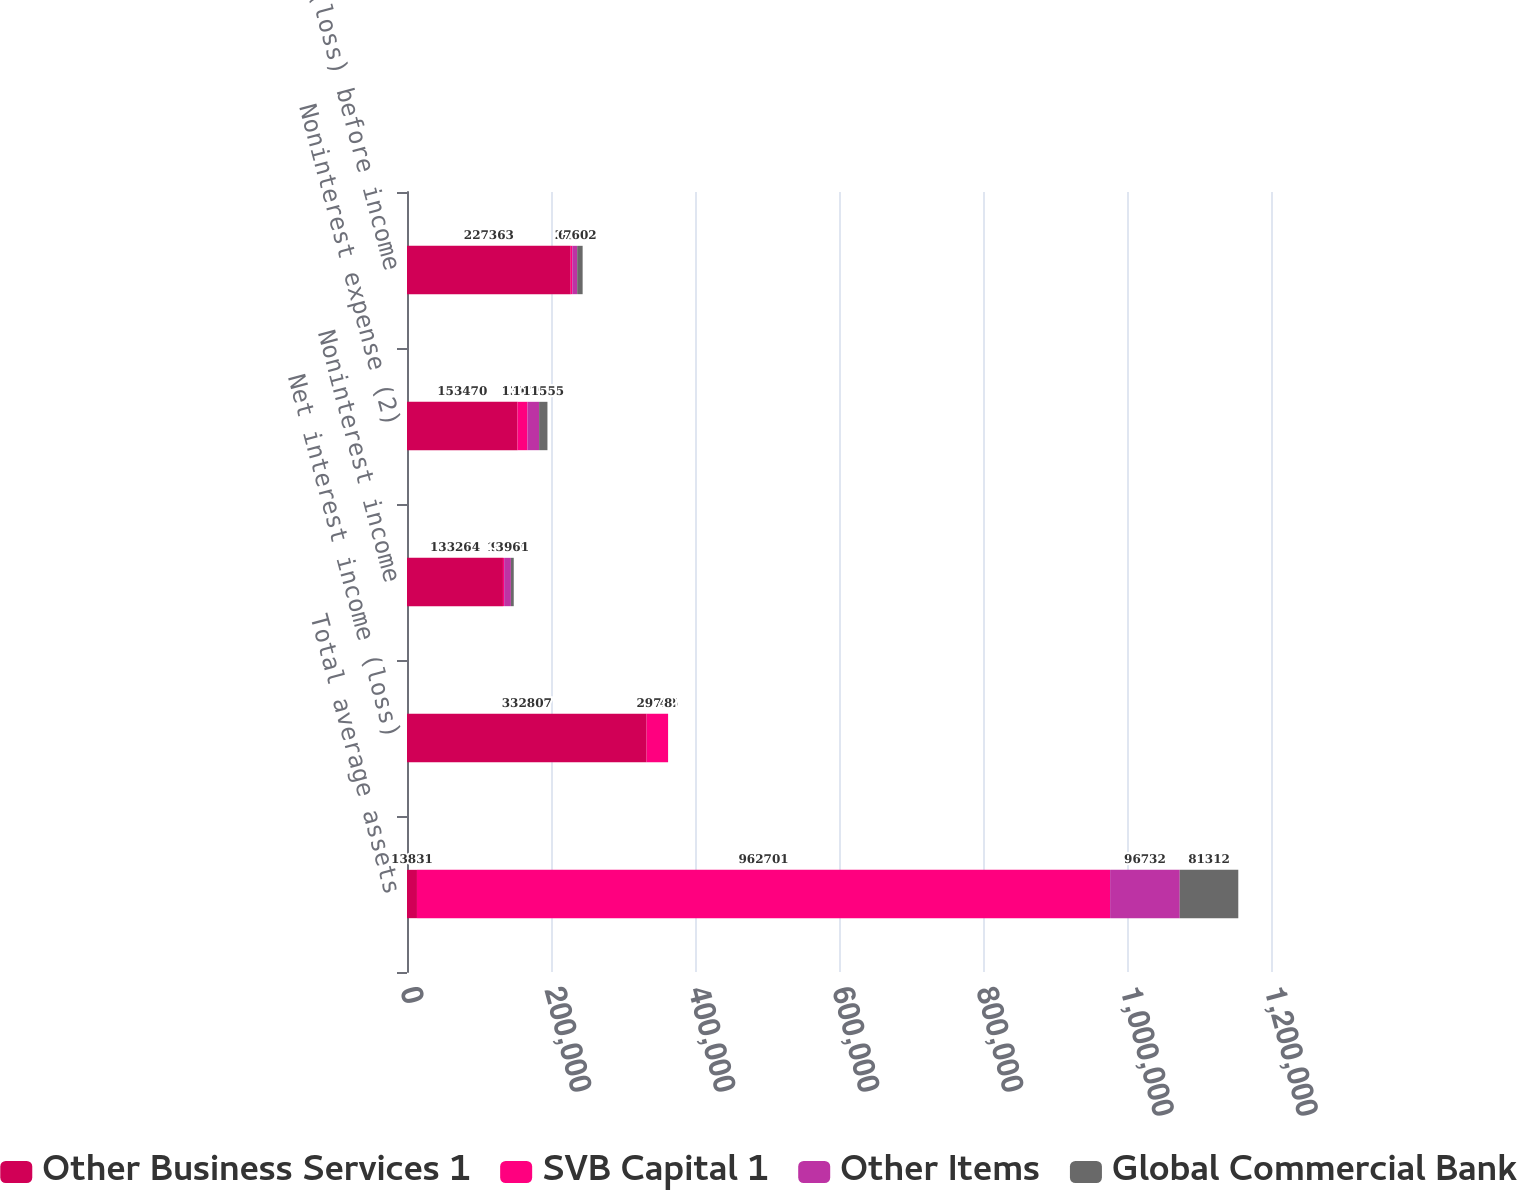<chart> <loc_0><loc_0><loc_500><loc_500><stacked_bar_chart><ecel><fcel>Total average assets<fcel>Net interest income (loss)<fcel>Noninterest income<fcel>Noninterest expense (2)<fcel>Income (loss) before income<nl><fcel>Other Business Services 1<fcel>13831<fcel>332807<fcel>133264<fcel>153470<fcel>227363<nl><fcel>SVB Capital 1<fcel>962701<fcel>29766<fcel>1673<fcel>13831<fcel>2167<nl><fcel>Other Items<fcel>96732<fcel>42<fcel>9360<fcel>16206<fcel>6804<nl><fcel>Global Commercial Bank<fcel>81312<fcel>8<fcel>3961<fcel>11555<fcel>7602<nl></chart> 